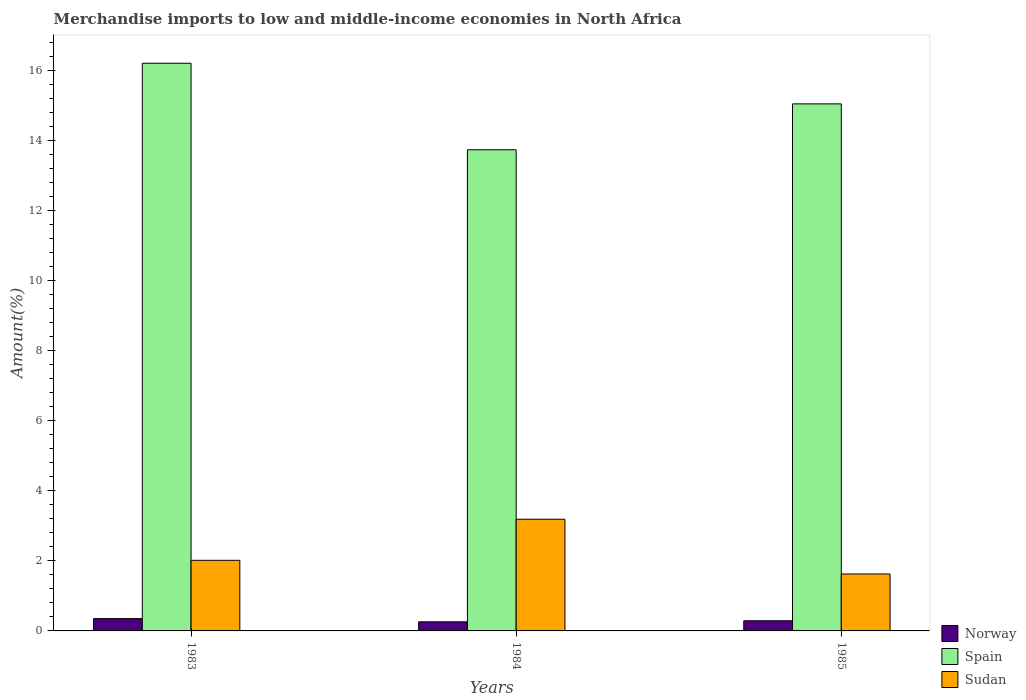How many different coloured bars are there?
Your answer should be very brief. 3. How many groups of bars are there?
Provide a short and direct response. 3. Are the number of bars per tick equal to the number of legend labels?
Give a very brief answer. Yes. Are the number of bars on each tick of the X-axis equal?
Offer a very short reply. Yes. How many bars are there on the 3rd tick from the left?
Your answer should be very brief. 3. How many bars are there on the 1st tick from the right?
Your response must be concise. 3. What is the label of the 3rd group of bars from the left?
Your response must be concise. 1985. In how many cases, is the number of bars for a given year not equal to the number of legend labels?
Offer a terse response. 0. What is the percentage of amount earned from merchandise imports in Norway in 1985?
Your answer should be compact. 0.29. Across all years, what is the maximum percentage of amount earned from merchandise imports in Spain?
Make the answer very short. 16.2. Across all years, what is the minimum percentage of amount earned from merchandise imports in Norway?
Make the answer very short. 0.26. In which year was the percentage of amount earned from merchandise imports in Norway maximum?
Offer a terse response. 1983. In which year was the percentage of amount earned from merchandise imports in Norway minimum?
Provide a short and direct response. 1984. What is the total percentage of amount earned from merchandise imports in Sudan in the graph?
Offer a terse response. 6.83. What is the difference between the percentage of amount earned from merchandise imports in Spain in 1984 and that in 1985?
Your answer should be very brief. -1.31. What is the difference between the percentage of amount earned from merchandise imports in Norway in 1983 and the percentage of amount earned from merchandise imports in Spain in 1984?
Your answer should be very brief. -13.38. What is the average percentage of amount earned from merchandise imports in Norway per year?
Your answer should be compact. 0.3. In the year 1985, what is the difference between the percentage of amount earned from merchandise imports in Spain and percentage of amount earned from merchandise imports in Sudan?
Ensure brevity in your answer.  13.42. What is the ratio of the percentage of amount earned from merchandise imports in Spain in 1984 to that in 1985?
Keep it short and to the point. 0.91. Is the difference between the percentage of amount earned from merchandise imports in Spain in 1984 and 1985 greater than the difference between the percentage of amount earned from merchandise imports in Sudan in 1984 and 1985?
Provide a succinct answer. No. What is the difference between the highest and the second highest percentage of amount earned from merchandise imports in Norway?
Provide a short and direct response. 0.06. What is the difference between the highest and the lowest percentage of amount earned from merchandise imports in Norway?
Give a very brief answer. 0.09. In how many years, is the percentage of amount earned from merchandise imports in Spain greater than the average percentage of amount earned from merchandise imports in Spain taken over all years?
Your response must be concise. 2. Is the sum of the percentage of amount earned from merchandise imports in Norway in 1983 and 1985 greater than the maximum percentage of amount earned from merchandise imports in Sudan across all years?
Make the answer very short. No. What does the 1st bar from the left in 1985 represents?
Ensure brevity in your answer.  Norway. What does the 2nd bar from the right in 1985 represents?
Your response must be concise. Spain. Is it the case that in every year, the sum of the percentage of amount earned from merchandise imports in Spain and percentage of amount earned from merchandise imports in Norway is greater than the percentage of amount earned from merchandise imports in Sudan?
Your answer should be very brief. Yes. How many years are there in the graph?
Provide a short and direct response. 3. What is the difference between two consecutive major ticks on the Y-axis?
Your response must be concise. 2. Are the values on the major ticks of Y-axis written in scientific E-notation?
Provide a succinct answer. No. Does the graph contain any zero values?
Make the answer very short. No. Does the graph contain grids?
Your answer should be very brief. No. Where does the legend appear in the graph?
Ensure brevity in your answer.  Bottom right. What is the title of the graph?
Provide a short and direct response. Merchandise imports to low and middle-income economies in North Africa. Does "Guatemala" appear as one of the legend labels in the graph?
Your response must be concise. No. What is the label or title of the X-axis?
Make the answer very short. Years. What is the label or title of the Y-axis?
Your answer should be compact. Amount(%). What is the Amount(%) in Norway in 1983?
Keep it short and to the point. 0.35. What is the Amount(%) of Spain in 1983?
Make the answer very short. 16.2. What is the Amount(%) in Sudan in 1983?
Give a very brief answer. 2.01. What is the Amount(%) of Norway in 1984?
Provide a succinct answer. 0.26. What is the Amount(%) in Spain in 1984?
Provide a succinct answer. 13.73. What is the Amount(%) of Sudan in 1984?
Provide a succinct answer. 3.19. What is the Amount(%) of Norway in 1985?
Make the answer very short. 0.29. What is the Amount(%) of Spain in 1985?
Offer a terse response. 15.04. What is the Amount(%) in Sudan in 1985?
Provide a succinct answer. 1.62. Across all years, what is the maximum Amount(%) in Norway?
Your answer should be compact. 0.35. Across all years, what is the maximum Amount(%) of Spain?
Give a very brief answer. 16.2. Across all years, what is the maximum Amount(%) in Sudan?
Provide a succinct answer. 3.19. Across all years, what is the minimum Amount(%) in Norway?
Give a very brief answer. 0.26. Across all years, what is the minimum Amount(%) in Spain?
Your answer should be compact. 13.73. Across all years, what is the minimum Amount(%) of Sudan?
Offer a terse response. 1.62. What is the total Amount(%) in Norway in the graph?
Your answer should be compact. 0.9. What is the total Amount(%) of Spain in the graph?
Your response must be concise. 44.98. What is the total Amount(%) in Sudan in the graph?
Provide a succinct answer. 6.83. What is the difference between the Amount(%) in Norway in 1983 and that in 1984?
Your answer should be compact. 0.09. What is the difference between the Amount(%) of Spain in 1983 and that in 1984?
Your response must be concise. 2.47. What is the difference between the Amount(%) of Sudan in 1983 and that in 1984?
Give a very brief answer. -1.17. What is the difference between the Amount(%) in Norway in 1983 and that in 1985?
Give a very brief answer. 0.06. What is the difference between the Amount(%) in Spain in 1983 and that in 1985?
Keep it short and to the point. 1.16. What is the difference between the Amount(%) of Sudan in 1983 and that in 1985?
Your response must be concise. 0.39. What is the difference between the Amount(%) in Norway in 1984 and that in 1985?
Give a very brief answer. -0.03. What is the difference between the Amount(%) of Spain in 1984 and that in 1985?
Ensure brevity in your answer.  -1.31. What is the difference between the Amount(%) in Sudan in 1984 and that in 1985?
Offer a very short reply. 1.56. What is the difference between the Amount(%) in Norway in 1983 and the Amount(%) in Spain in 1984?
Offer a terse response. -13.38. What is the difference between the Amount(%) in Norway in 1983 and the Amount(%) in Sudan in 1984?
Offer a very short reply. -2.84. What is the difference between the Amount(%) of Spain in 1983 and the Amount(%) of Sudan in 1984?
Make the answer very short. 13.01. What is the difference between the Amount(%) in Norway in 1983 and the Amount(%) in Spain in 1985?
Your answer should be compact. -14.69. What is the difference between the Amount(%) of Norway in 1983 and the Amount(%) of Sudan in 1985?
Make the answer very short. -1.27. What is the difference between the Amount(%) in Spain in 1983 and the Amount(%) in Sudan in 1985?
Your answer should be compact. 14.58. What is the difference between the Amount(%) of Norway in 1984 and the Amount(%) of Spain in 1985?
Make the answer very short. -14.78. What is the difference between the Amount(%) in Norway in 1984 and the Amount(%) in Sudan in 1985?
Offer a very short reply. -1.36. What is the difference between the Amount(%) in Spain in 1984 and the Amount(%) in Sudan in 1985?
Offer a very short reply. 12.11. What is the average Amount(%) of Norway per year?
Give a very brief answer. 0.3. What is the average Amount(%) of Spain per year?
Offer a very short reply. 14.99. What is the average Amount(%) of Sudan per year?
Keep it short and to the point. 2.28. In the year 1983, what is the difference between the Amount(%) of Norway and Amount(%) of Spain?
Your answer should be compact. -15.85. In the year 1983, what is the difference between the Amount(%) in Norway and Amount(%) in Sudan?
Provide a short and direct response. -1.66. In the year 1983, what is the difference between the Amount(%) in Spain and Amount(%) in Sudan?
Offer a very short reply. 14.19. In the year 1984, what is the difference between the Amount(%) of Norway and Amount(%) of Spain?
Offer a very short reply. -13.47. In the year 1984, what is the difference between the Amount(%) of Norway and Amount(%) of Sudan?
Provide a short and direct response. -2.93. In the year 1984, what is the difference between the Amount(%) of Spain and Amount(%) of Sudan?
Your answer should be very brief. 10.55. In the year 1985, what is the difference between the Amount(%) in Norway and Amount(%) in Spain?
Your response must be concise. -14.75. In the year 1985, what is the difference between the Amount(%) in Norway and Amount(%) in Sudan?
Provide a succinct answer. -1.34. In the year 1985, what is the difference between the Amount(%) in Spain and Amount(%) in Sudan?
Provide a short and direct response. 13.42. What is the ratio of the Amount(%) of Norway in 1983 to that in 1984?
Your answer should be very brief. 1.35. What is the ratio of the Amount(%) of Spain in 1983 to that in 1984?
Offer a terse response. 1.18. What is the ratio of the Amount(%) of Sudan in 1983 to that in 1984?
Your answer should be very brief. 0.63. What is the ratio of the Amount(%) in Norway in 1983 to that in 1985?
Your response must be concise. 1.21. What is the ratio of the Amount(%) of Spain in 1983 to that in 1985?
Provide a succinct answer. 1.08. What is the ratio of the Amount(%) of Sudan in 1983 to that in 1985?
Provide a succinct answer. 1.24. What is the ratio of the Amount(%) of Norway in 1984 to that in 1985?
Make the answer very short. 0.9. What is the ratio of the Amount(%) of Spain in 1984 to that in 1985?
Provide a succinct answer. 0.91. What is the ratio of the Amount(%) of Sudan in 1984 to that in 1985?
Ensure brevity in your answer.  1.96. What is the difference between the highest and the second highest Amount(%) of Norway?
Offer a terse response. 0.06. What is the difference between the highest and the second highest Amount(%) in Spain?
Make the answer very short. 1.16. What is the difference between the highest and the second highest Amount(%) of Sudan?
Keep it short and to the point. 1.17. What is the difference between the highest and the lowest Amount(%) of Norway?
Your answer should be very brief. 0.09. What is the difference between the highest and the lowest Amount(%) of Spain?
Keep it short and to the point. 2.47. What is the difference between the highest and the lowest Amount(%) in Sudan?
Your answer should be very brief. 1.56. 